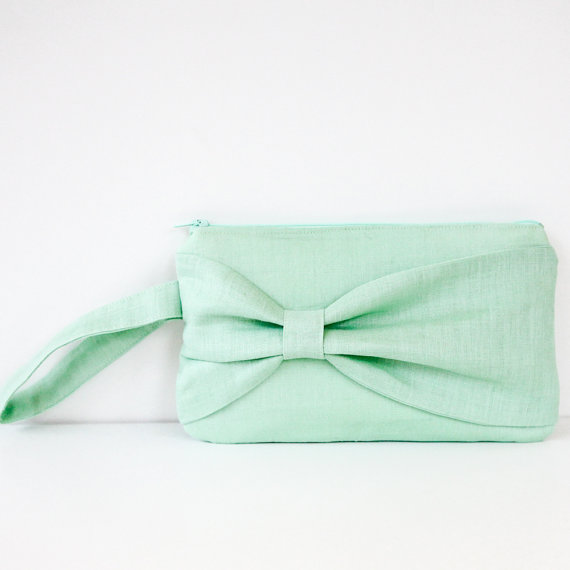Imagine a story where this clutch purse is a magical artifact. What powers does it possess, and how does the protagonist use it? In the enchanted world of Eldoria, the mint green clutch purse is not just an accessory but a powerful artifact known as the 'Bow of Serenity.' Crafted by ancient artisans, it has the ability to grant the wearer calming spells that soothe turbulent minds and quell chaos in a tumultuous environment. Lucia, the young protagonist and guardian of the purse, discovers its powers during a volatile time in her village. With a gentle wave of the purse's bow, she casts a serene glow that pacifies feuding neighbors and brings tranquility to troubled souls. As Lucia becomes attuned to the purse's magic, she learns to summon protective barriers against dark forces, turning the stylish clutch into a beacon of peace and unity in Eldoria. 